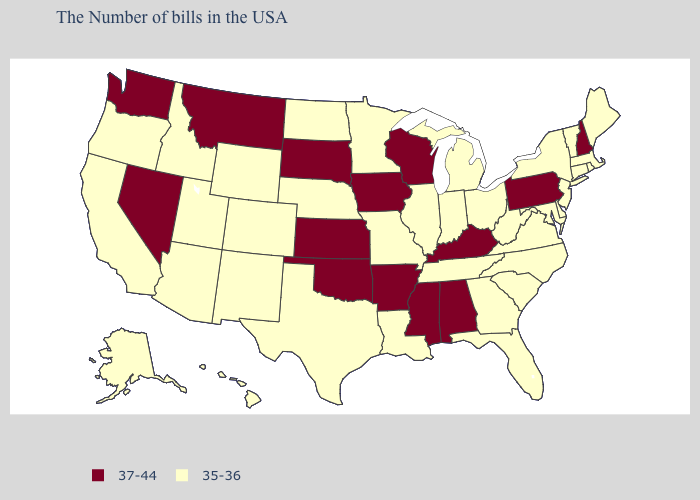Name the states that have a value in the range 37-44?
Quick response, please. New Hampshire, Pennsylvania, Kentucky, Alabama, Wisconsin, Mississippi, Arkansas, Iowa, Kansas, Oklahoma, South Dakota, Montana, Nevada, Washington. What is the lowest value in states that border South Dakota?
Be succinct. 35-36. What is the value of Alabama?
Short answer required. 37-44. Does South Dakota have the highest value in the USA?
Write a very short answer. Yes. Among the states that border California , does Oregon have the lowest value?
Keep it brief. Yes. Name the states that have a value in the range 37-44?
Write a very short answer. New Hampshire, Pennsylvania, Kentucky, Alabama, Wisconsin, Mississippi, Arkansas, Iowa, Kansas, Oklahoma, South Dakota, Montana, Nevada, Washington. What is the lowest value in the Northeast?
Give a very brief answer. 35-36. Does South Dakota have a lower value than Alaska?
Be succinct. No. Among the states that border Rhode Island , which have the lowest value?
Write a very short answer. Massachusetts, Connecticut. Which states have the lowest value in the USA?
Answer briefly. Maine, Massachusetts, Rhode Island, Vermont, Connecticut, New York, New Jersey, Delaware, Maryland, Virginia, North Carolina, South Carolina, West Virginia, Ohio, Florida, Georgia, Michigan, Indiana, Tennessee, Illinois, Louisiana, Missouri, Minnesota, Nebraska, Texas, North Dakota, Wyoming, Colorado, New Mexico, Utah, Arizona, Idaho, California, Oregon, Alaska, Hawaii. What is the value of Nebraska?
Concise answer only. 35-36. Does New Hampshire have the lowest value in the USA?
Keep it brief. No. What is the value of South Carolina?
Keep it brief. 35-36. 